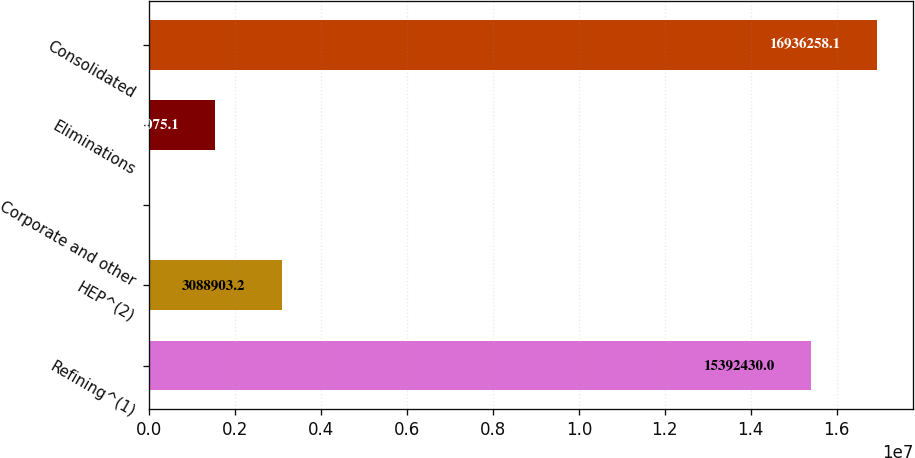Convert chart. <chart><loc_0><loc_0><loc_500><loc_500><bar_chart><fcel>Refining^(1)<fcel>HEP^(2)<fcel>Corporate and other<fcel>Eliminations<fcel>Consolidated<nl><fcel>1.53924e+07<fcel>3.0889e+06<fcel>1247<fcel>1.54508e+06<fcel>1.69363e+07<nl></chart> 